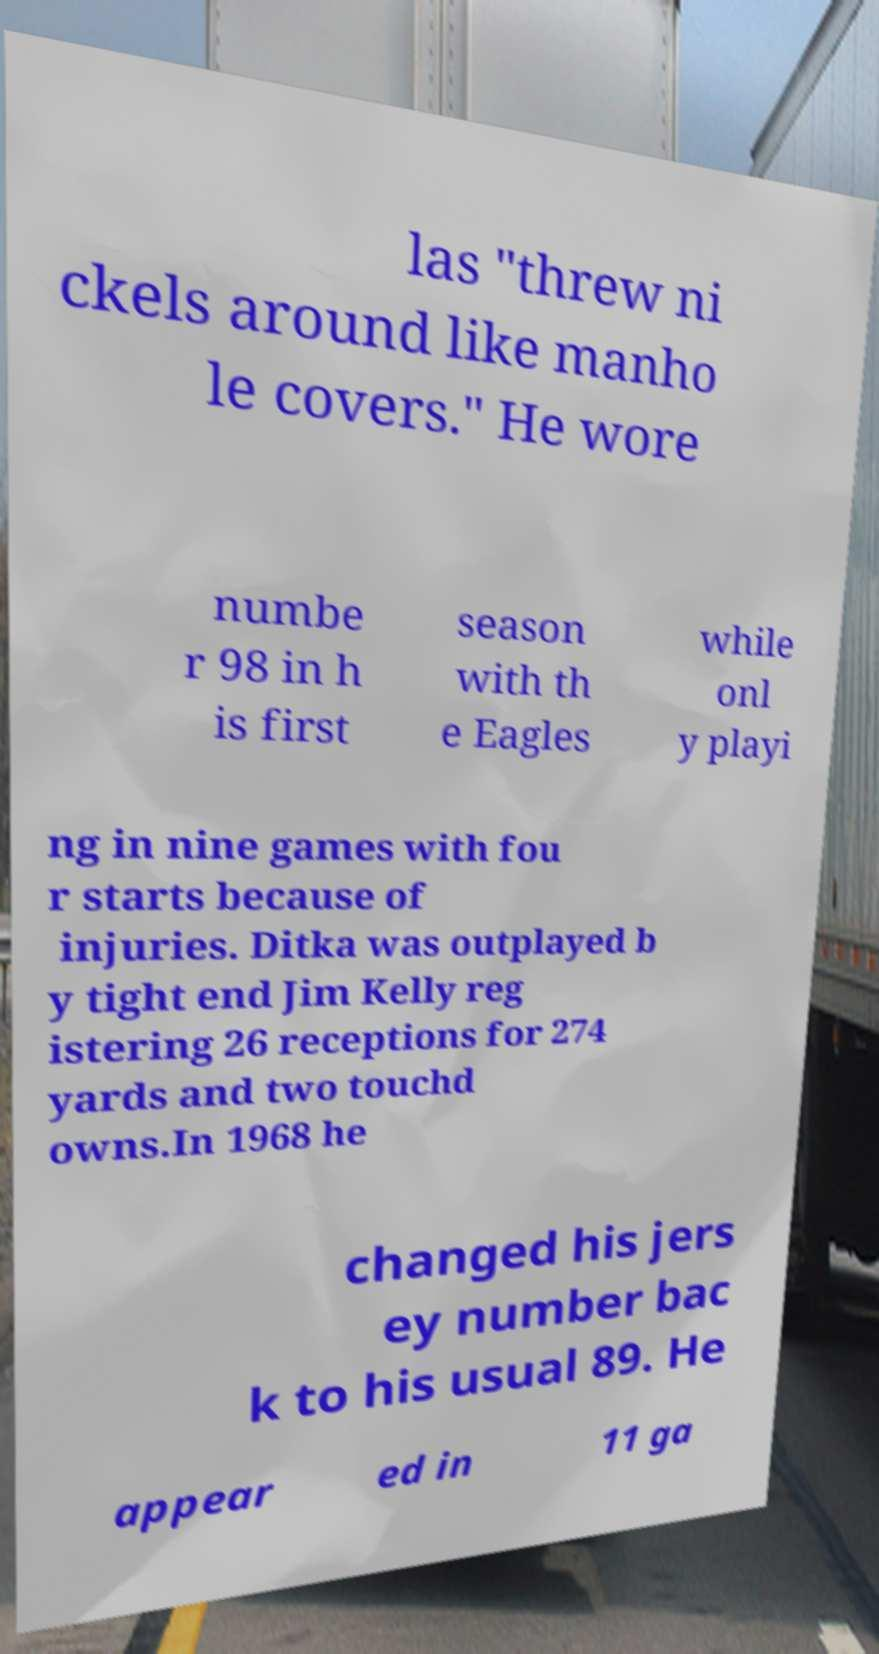Please identify and transcribe the text found in this image. las "threw ni ckels around like manho le covers." He wore numbe r 98 in h is first season with th e Eagles while onl y playi ng in nine games with fou r starts because of injuries. Ditka was outplayed b y tight end Jim Kelly reg istering 26 receptions for 274 yards and two touchd owns.In 1968 he changed his jers ey number bac k to his usual 89. He appear ed in 11 ga 